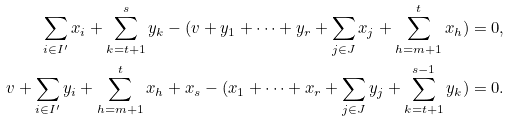Convert formula to latex. <formula><loc_0><loc_0><loc_500><loc_500>\sum _ { i \in I ^ { \prime } } x _ { i } + \sum _ { k = t + 1 } ^ { s } y _ { k } - ( v + y _ { 1 } + \cdots + y _ { r } + \sum _ { j \in J } x _ { j } + \sum _ { h = m + 1 } ^ { t } x _ { h } ) = 0 , \\ v + \sum _ { i \in I ^ { \prime } } y _ { i } + \sum _ { h = m + 1 } ^ { t } x _ { h } + x _ { s } - ( x _ { 1 } + \cdots + x _ { r } + \sum _ { j \in J } y _ { j } + \sum _ { k = t + 1 } ^ { s - 1 } y _ { k } ) = 0 .</formula> 